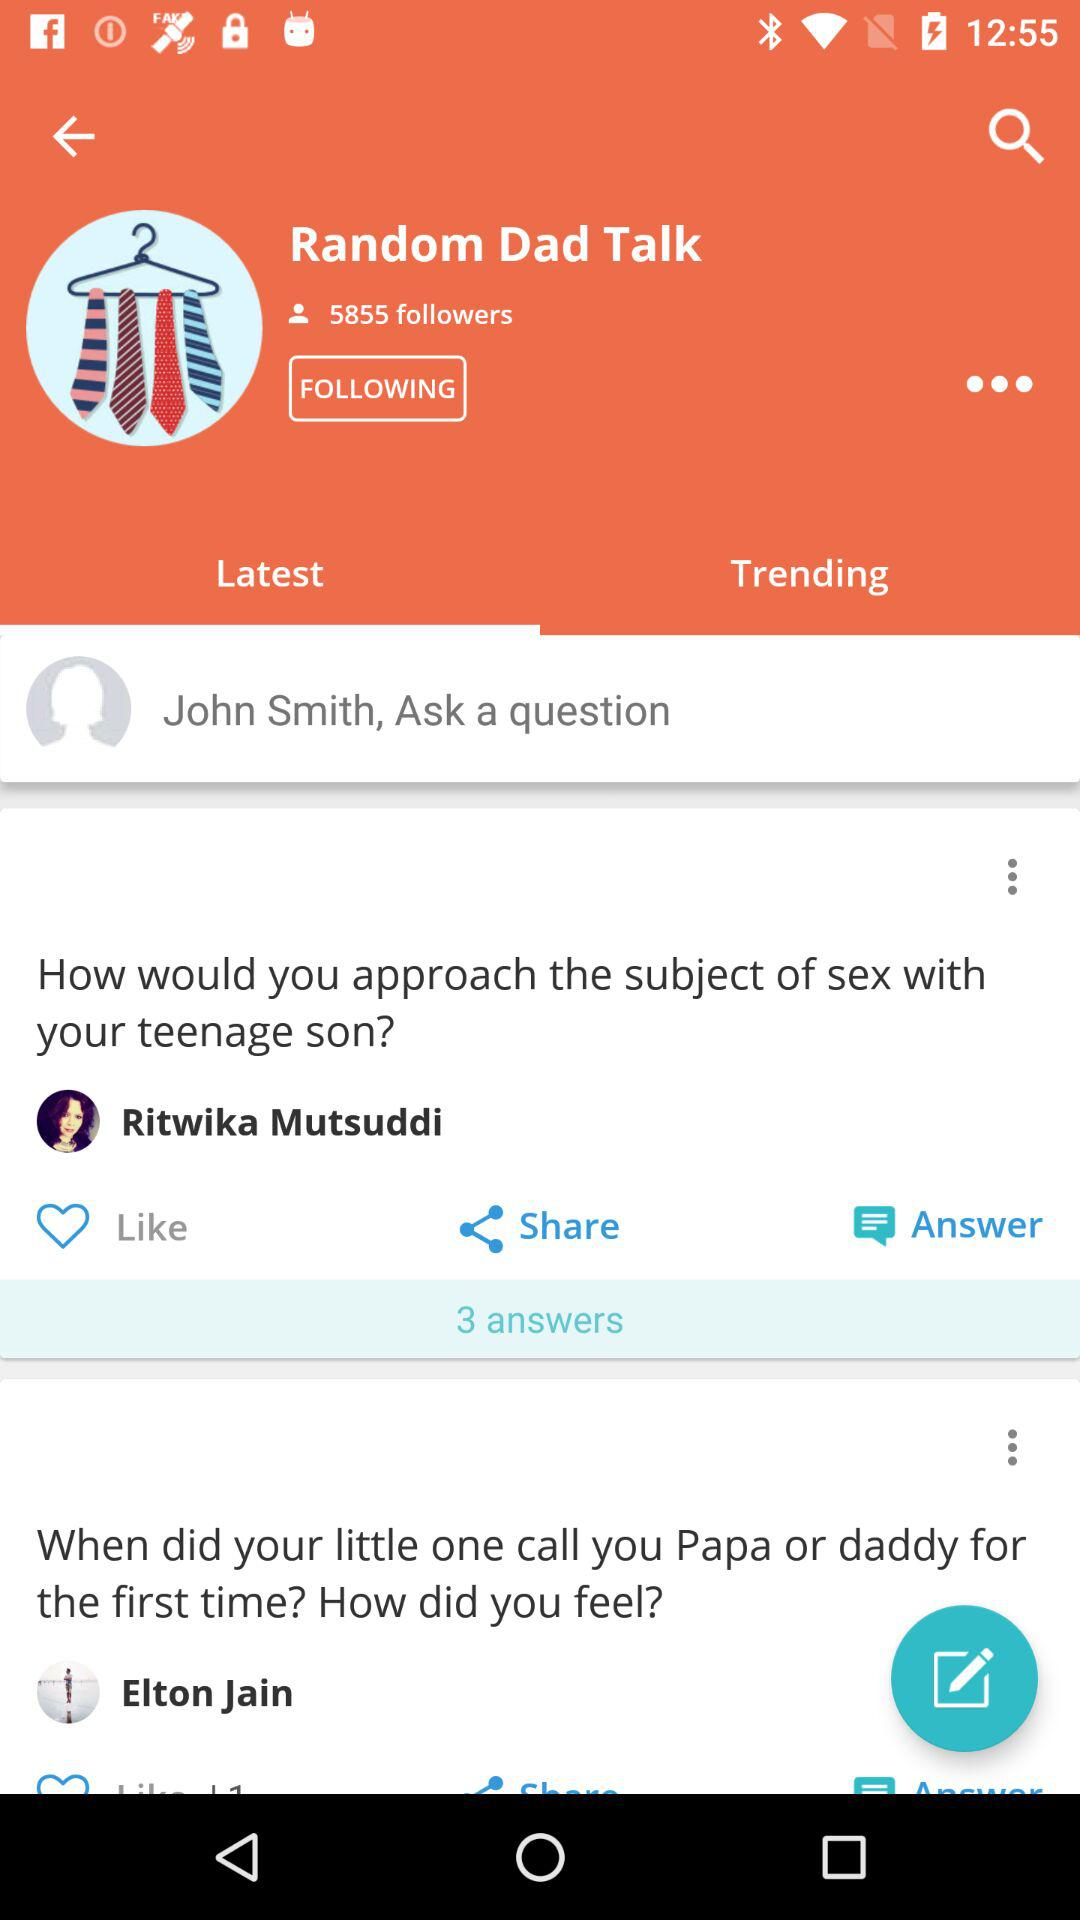How many answers are there to the question 'How would you approach the subject of sex with your teenage son?'?
Answer the question using a single word or phrase. 3 